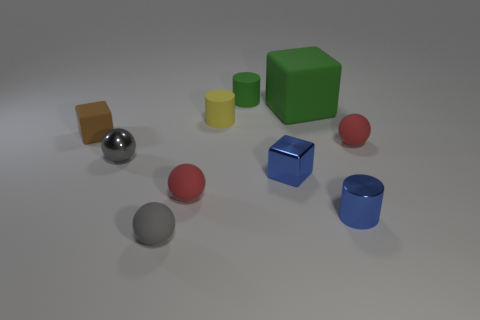Subtract all green spheres. Subtract all brown cubes. How many spheres are left? 4 Subtract all balls. How many objects are left? 6 Subtract all small rubber cubes. Subtract all tiny green cylinders. How many objects are left? 8 Add 2 small brown matte cubes. How many small brown matte cubes are left? 3 Add 2 red metal blocks. How many red metal blocks exist? 2 Subtract 1 brown blocks. How many objects are left? 9 